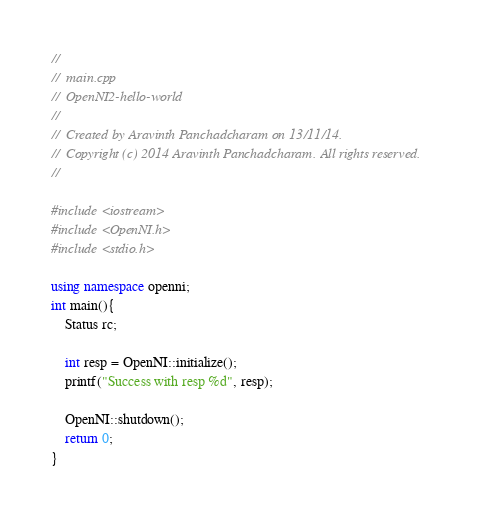Convert code to text. <code><loc_0><loc_0><loc_500><loc_500><_C++_>//
//  main.cpp
//  OpenNI2-hello-world
//
//  Created by Aravinth Panchadcharam on 13/11/14.
//  Copyright (c) 2014 Aravinth Panchadcharam. All rights reserved.
//

#include <iostream>
#include <OpenNI.h>
#include <stdio.h>

using namespace openni;
int main(){
    Status rc;
    
    int resp = OpenNI::initialize();
    printf("Success with resp %d", resp);
   
    OpenNI::shutdown();
    return 0;
}
</code> 